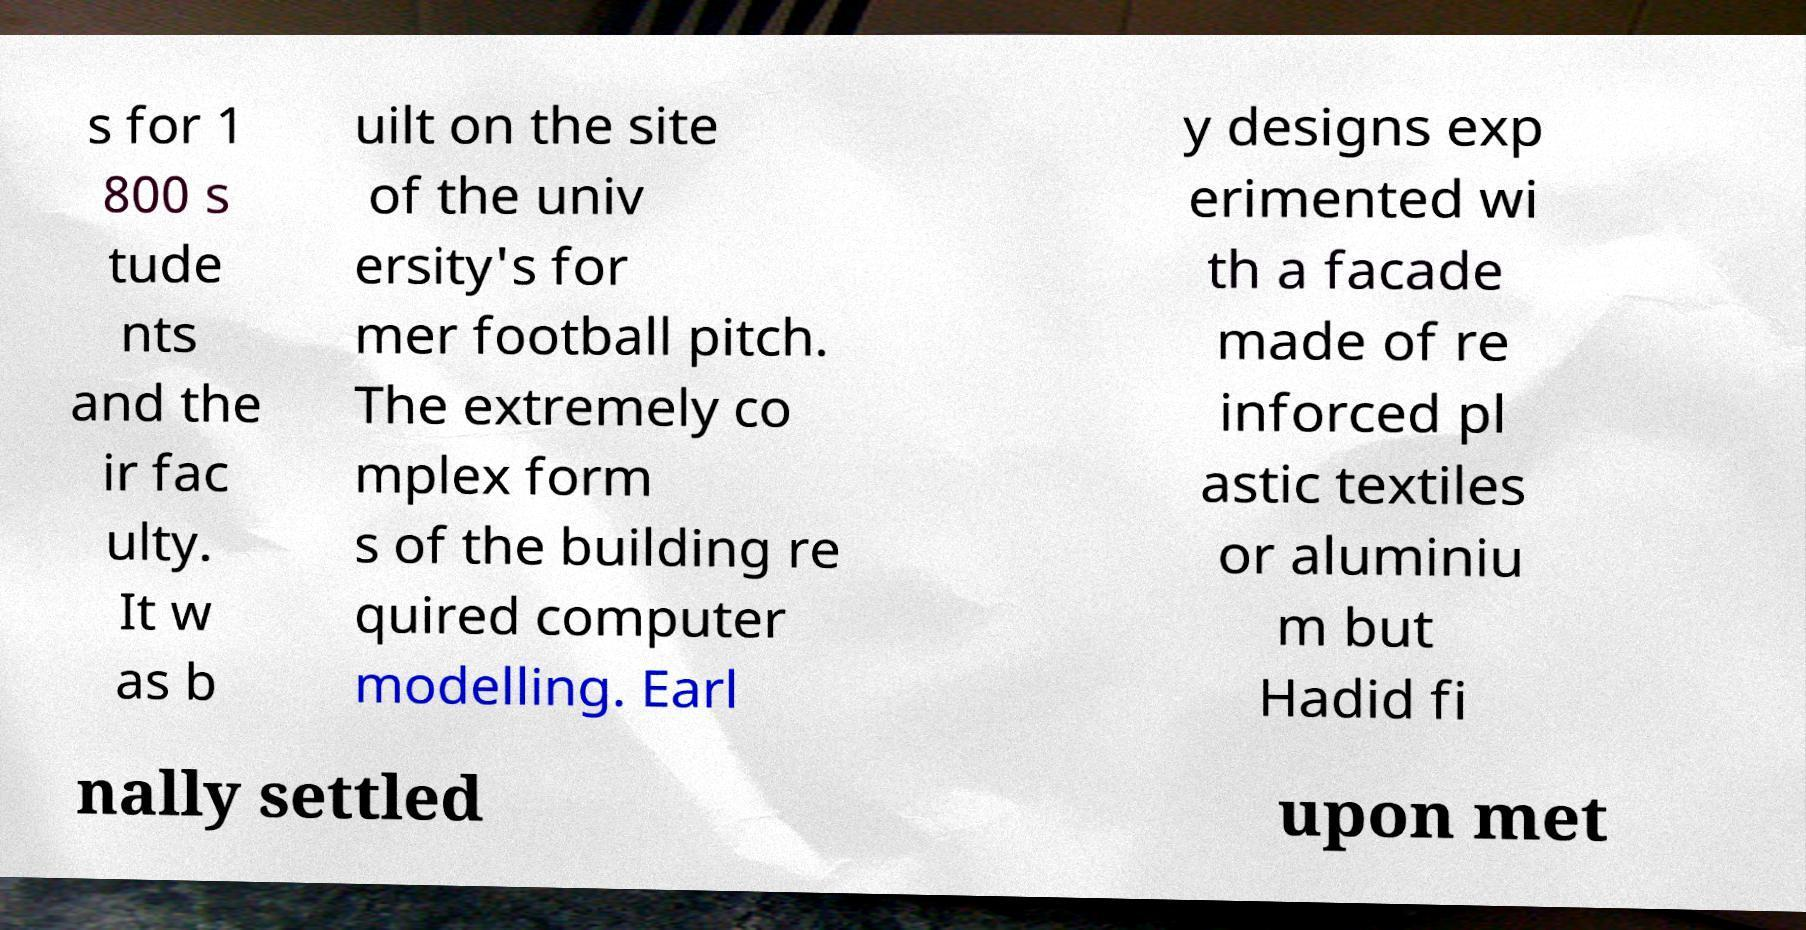What messages or text are displayed in this image? I need them in a readable, typed format. s for 1 800 s tude nts and the ir fac ulty. It w as b uilt on the site of the univ ersity's for mer football pitch. The extremely co mplex form s of the building re quired computer modelling. Earl y designs exp erimented wi th a facade made of re inforced pl astic textiles or aluminiu m but Hadid fi nally settled upon met 